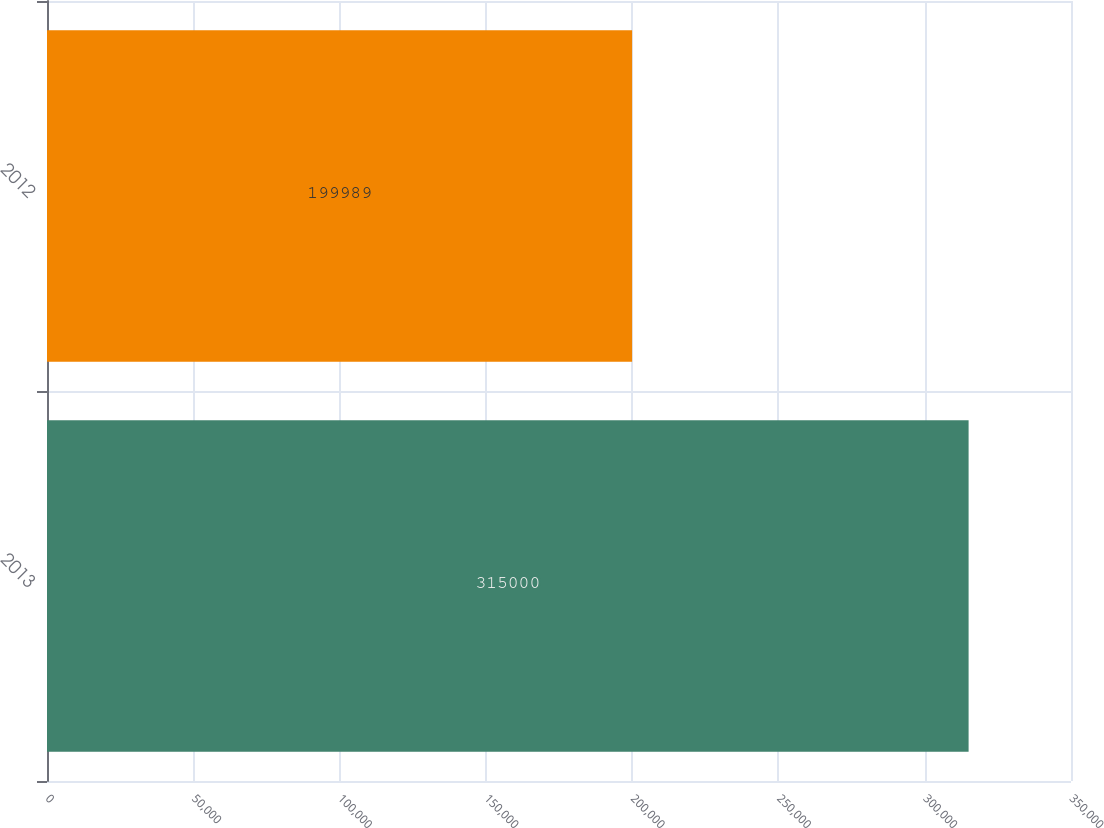<chart> <loc_0><loc_0><loc_500><loc_500><bar_chart><fcel>2013<fcel>2012<nl><fcel>315000<fcel>199989<nl></chart> 